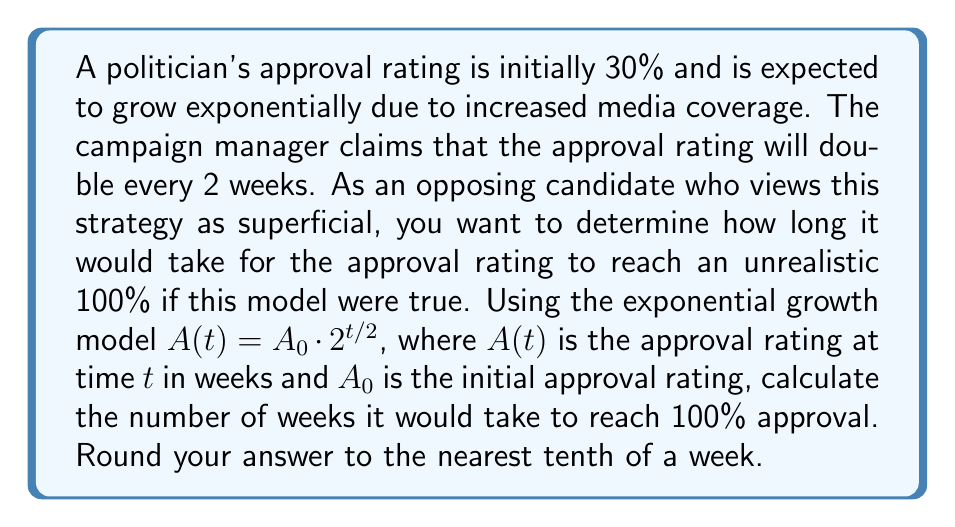Show me your answer to this math problem. Let's approach this step-by-step:

1) We start with the exponential growth model:
   $A(t) = A_0 \cdot 2^{t/2}$

2) We know:
   $A_0 = 30\%$ (initial approval rating)
   $A(t) = 100\%$ (target approval rating)

3) Let's substitute these values into the equation:
   $100 = 30 \cdot 2^{t/2}$

4) Divide both sides by 30:
   $\frac{100}{30} = 2^{t/2}$

5) Simplify:
   $\frac{10}{3} = 2^{t/2}$

6) Take the logarithm (base 2) of both sides:
   $\log_2(\frac{10}{3}) = \log_2(2^{t/2})$

7) Simplify the right side using logarithm properties:
   $\log_2(\frac{10}{3}) = \frac{t}{2}$

8) Multiply both sides by 2:
   $2 \log_2(\frac{10}{3}) = t$

9) Calculate:
   $t = 2 \log_2(\frac{10}{3}) \approx 3.5389$ weeks

10) Round to the nearest tenth:
    $t \approx 3.5$ weeks

This unrealistically rapid growth demonstrates the superficial nature of relying solely on media coverage for approval ratings.
Answer: 3.5 weeks 